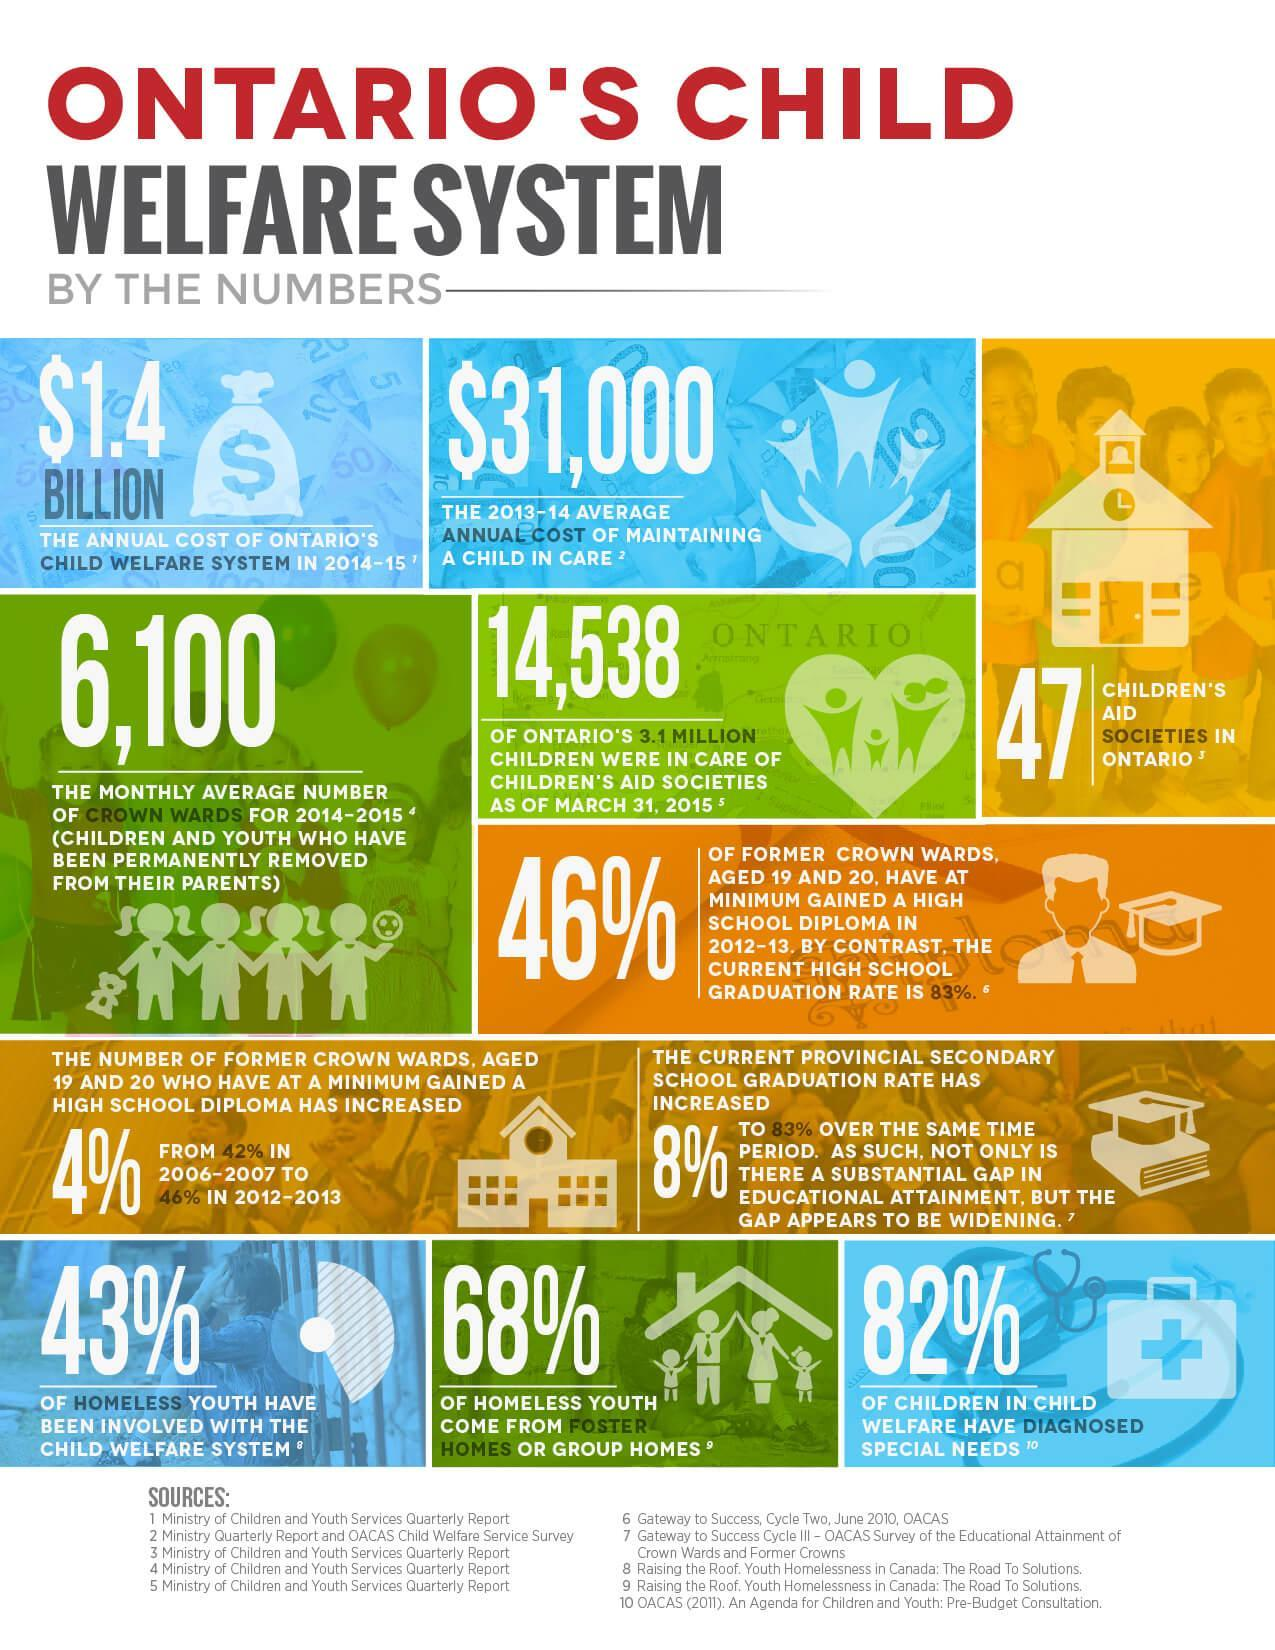What percentage of children in child welfare have not diagnosed with special needs?
Answer the question with a short phrase. 18% What percentage of homeless youth come from group homes? 68% What percentage of homeless youth have not been involved with the child welfare system? 57% 